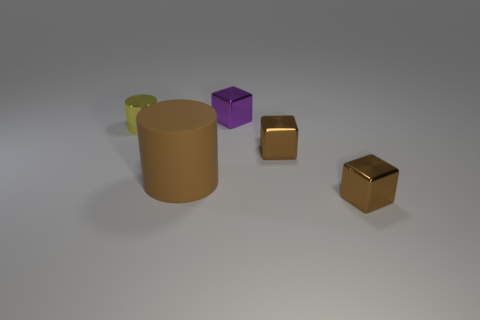Subtract all brown metallic blocks. How many blocks are left? 1 Subtract all brown cylinders. How many cylinders are left? 1 Add 4 big brown cylinders. How many objects exist? 9 Subtract 3 cubes. How many cubes are left? 0 Subtract 1 yellow cylinders. How many objects are left? 4 Subtract all blocks. How many objects are left? 2 Subtract all brown blocks. Subtract all red balls. How many blocks are left? 1 Subtract all purple balls. How many brown blocks are left? 2 Subtract all small purple shiny objects. Subtract all tiny brown metallic blocks. How many objects are left? 2 Add 3 shiny objects. How many shiny objects are left? 7 